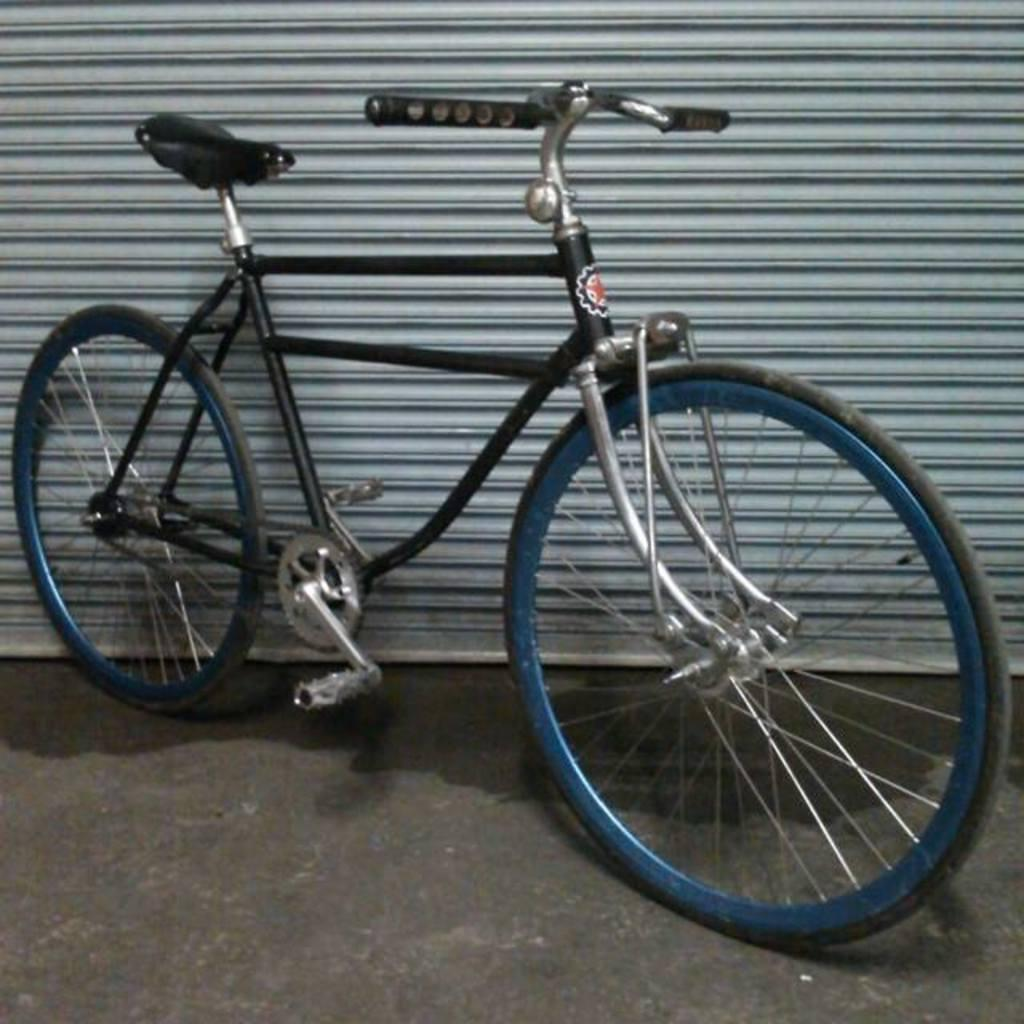What object is placed on the floor in the image? There is a bicycle on the floor in the image. What type of door or window covering is present in the image? There is a roller shutter in the image. What scene is being depicted in the middle of the tongue in the image? There is no tongue or scene present in the image; it features a bicycle on the floor and a roller shutter. 